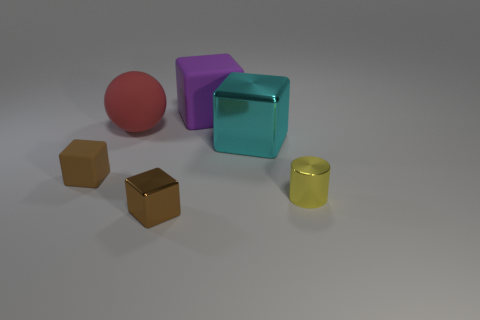Subtract all big matte blocks. How many blocks are left? 3 Add 1 big purple rubber objects. How many objects exist? 7 Subtract all spheres. How many objects are left? 5 Subtract all purple cubes. How many cubes are left? 3 Subtract 1 yellow cylinders. How many objects are left? 5 Subtract 1 cubes. How many cubes are left? 3 Subtract all cyan cubes. Subtract all green cylinders. How many cubes are left? 3 Subtract all brown cylinders. How many cyan blocks are left? 1 Subtract all small yellow metal objects. Subtract all red rubber balls. How many objects are left? 4 Add 5 tiny shiny objects. How many tiny shiny objects are left? 7 